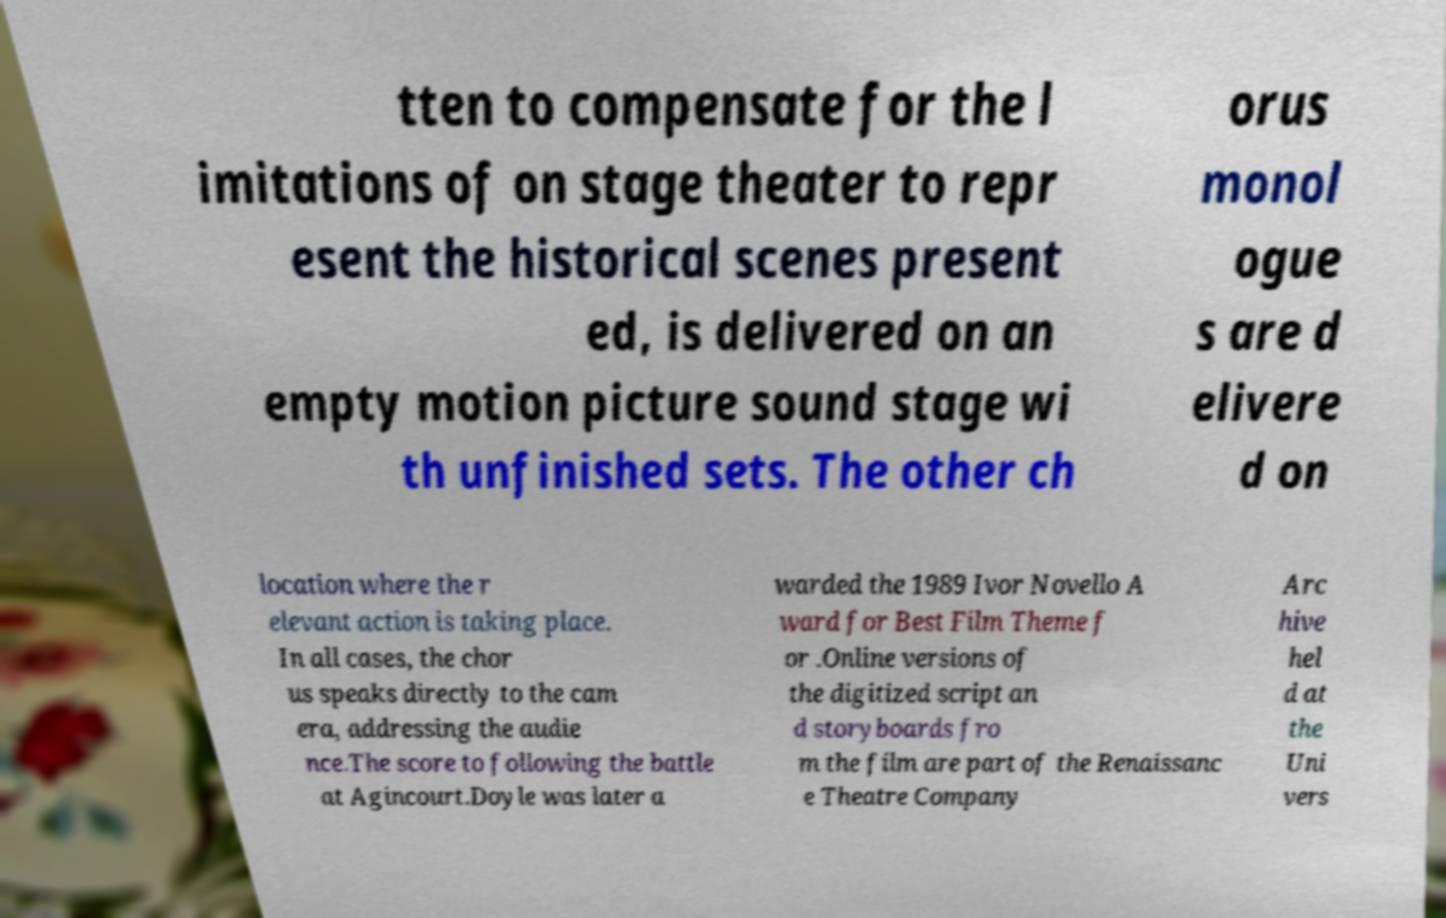Could you extract and type out the text from this image? tten to compensate for the l imitations of on stage theater to repr esent the historical scenes present ed, is delivered on an empty motion picture sound stage wi th unfinished sets. The other ch orus monol ogue s are d elivere d on location where the r elevant action is taking place. In all cases, the chor us speaks directly to the cam era, addressing the audie nce.The score to following the battle at Agincourt.Doyle was later a warded the 1989 Ivor Novello A ward for Best Film Theme f or .Online versions of the digitized script an d storyboards fro m the film are part of the Renaissanc e Theatre Company Arc hive hel d at the Uni vers 